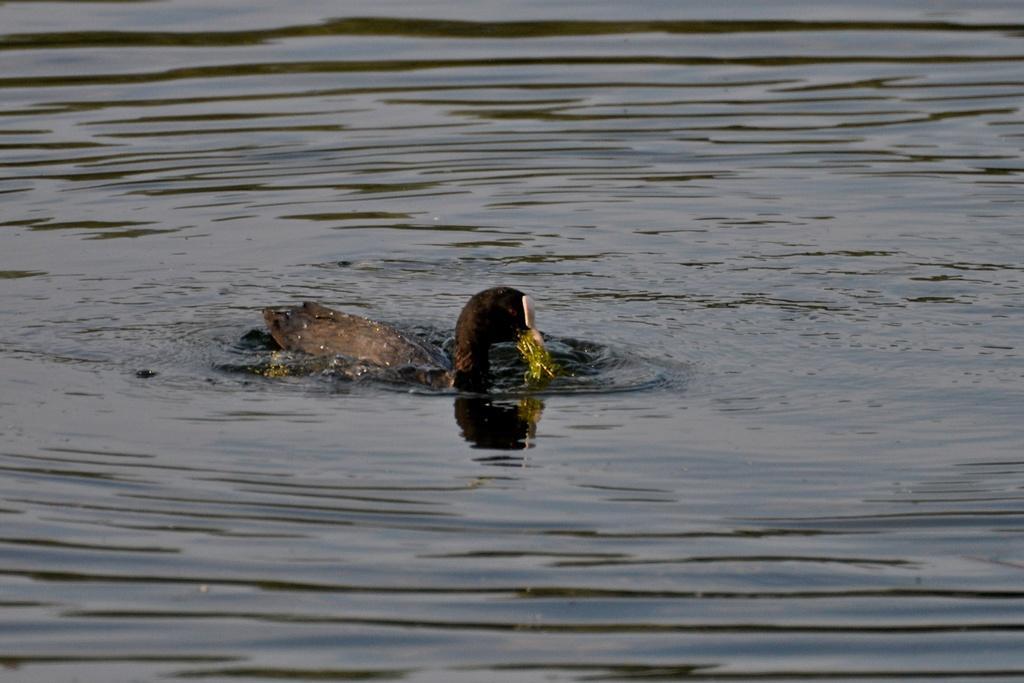In one or two sentences, can you explain what this image depicts? In this image we can see a duck swimming on the water. 